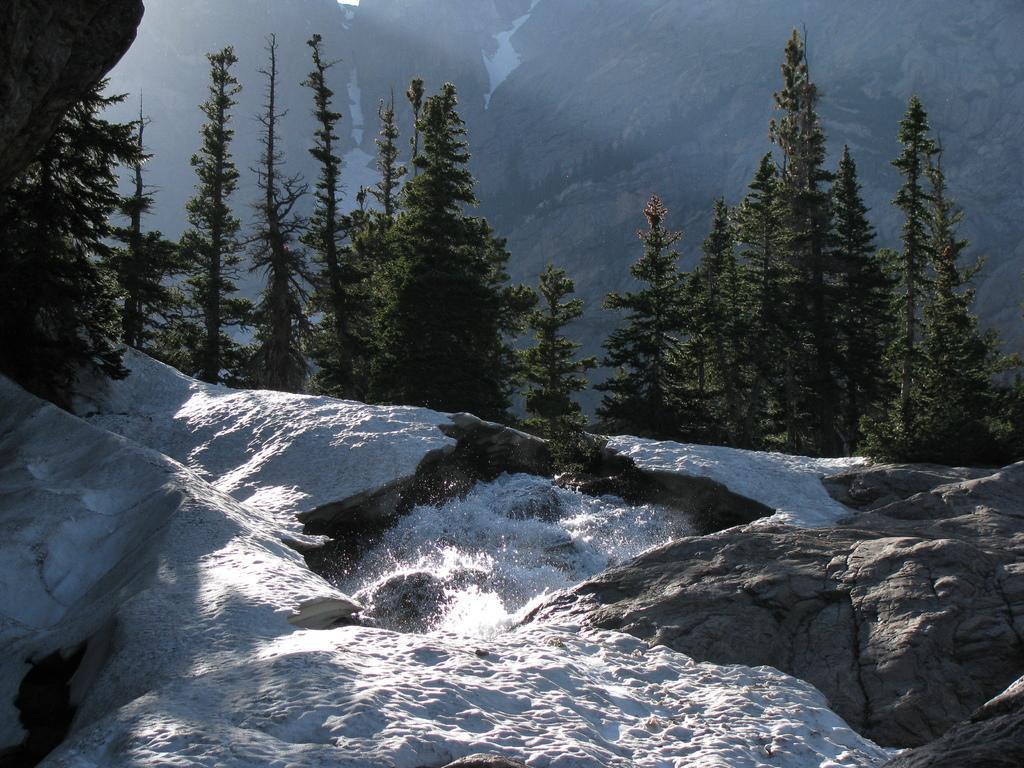Please provide a concise description of this image. In this picture I can see the snow on the rocks and in the background I can see number of trees and I can also see the mountains. 